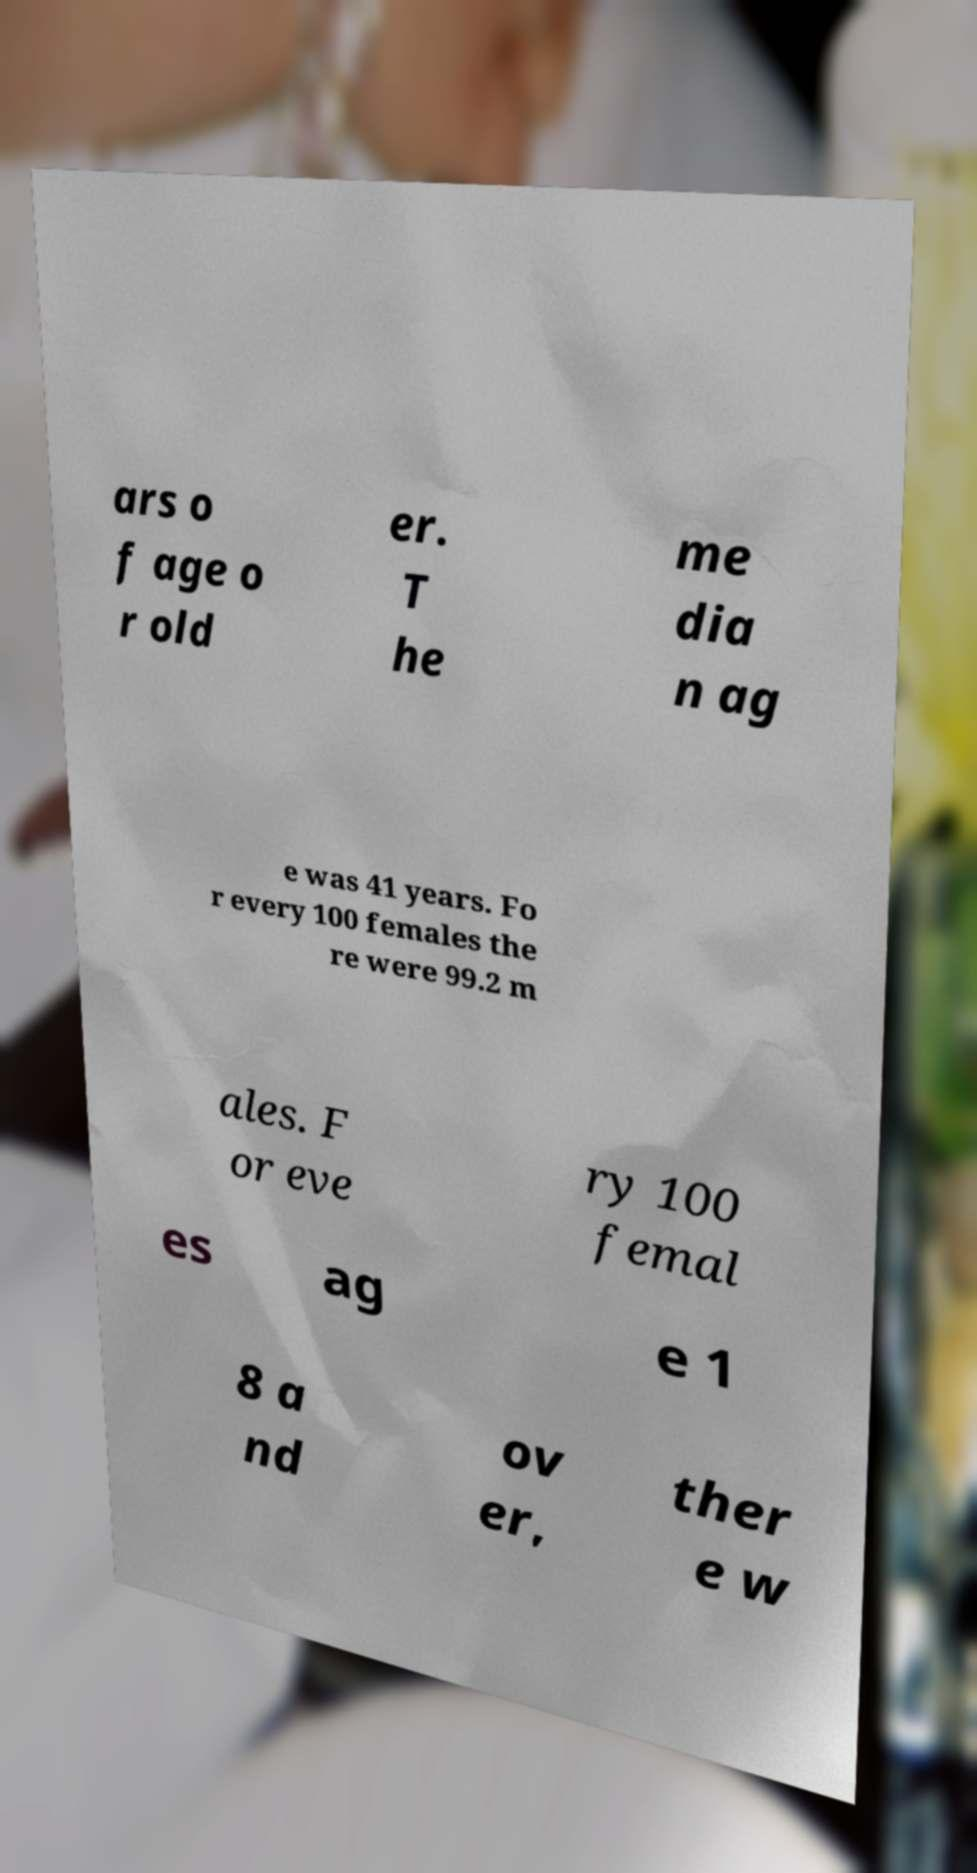For documentation purposes, I need the text within this image transcribed. Could you provide that? ars o f age o r old er. T he me dia n ag e was 41 years. Fo r every 100 females the re were 99.2 m ales. F or eve ry 100 femal es ag e 1 8 a nd ov er, ther e w 